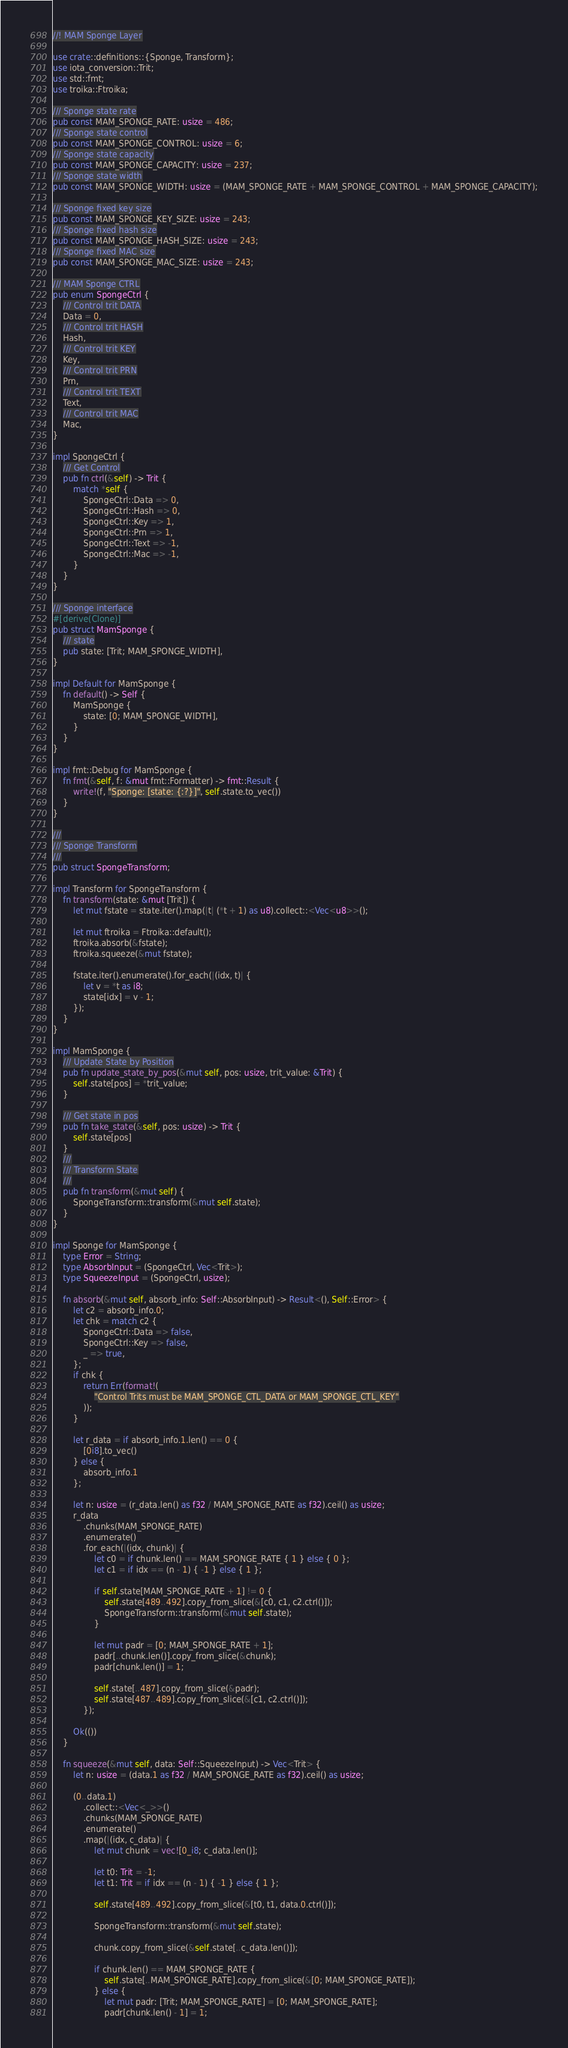<code> <loc_0><loc_0><loc_500><loc_500><_Rust_>//! MAM Sponge Layer

use crate::definitions::{Sponge, Transform};
use iota_conversion::Trit;
use std::fmt;
use troika::Ftroika;

/// Sponge state rate
pub const MAM_SPONGE_RATE: usize = 486;
/// Sponge state control
pub const MAM_SPONGE_CONTROL: usize = 6;
/// Sponge state capacity
pub const MAM_SPONGE_CAPACITY: usize = 237;
/// Sponge state width
pub const MAM_SPONGE_WIDTH: usize = (MAM_SPONGE_RATE + MAM_SPONGE_CONTROL + MAM_SPONGE_CAPACITY);

/// Sponge fixed key size
pub const MAM_SPONGE_KEY_SIZE: usize = 243;
/// Sponge fixed hash size
pub const MAM_SPONGE_HASH_SIZE: usize = 243;
/// Sponge fixed MAC size
pub const MAM_SPONGE_MAC_SIZE: usize = 243;

/// MAM Sponge CTRL
pub enum SpongeCtrl {
    /// Control trit DATA
    Data = 0,
    /// Control trit HASH
    Hash,
    /// Control trit KEY
    Key,
    /// Control trit PRN
    Prn,
    /// Control trit TEXT
    Text,
    /// Control trit MAC
    Mac,
}

impl SpongeCtrl {
    /// Get Control
    pub fn ctrl(&self) -> Trit {
        match *self {
            SpongeCtrl::Data => 0,
            SpongeCtrl::Hash => 0,
            SpongeCtrl::Key => 1,
            SpongeCtrl::Prn => 1,
            SpongeCtrl::Text => -1,
            SpongeCtrl::Mac => -1,
        }
    }
}

/// Sponge interface
#[derive(Clone)]
pub struct MamSponge {
    /// state
    pub state: [Trit; MAM_SPONGE_WIDTH],
}

impl Default for MamSponge {
    fn default() -> Self {
        MamSponge {
            state: [0; MAM_SPONGE_WIDTH],
        }
    }
}

impl fmt::Debug for MamSponge {
    fn fmt(&self, f: &mut fmt::Formatter) -> fmt::Result {
        write!(f, "Sponge: [state: {:?}]", self.state.to_vec())
    }
}

///
/// Sponge Transform
///
pub struct SpongeTransform;

impl Transform for SpongeTransform {
    fn transform(state: &mut [Trit]) {
        let mut fstate = state.iter().map(|t| (*t + 1) as u8).collect::<Vec<u8>>();

        let mut ftroika = Ftroika::default();
        ftroika.absorb(&fstate);
        ftroika.squeeze(&mut fstate);

        fstate.iter().enumerate().for_each(|(idx, t)| {
            let v = *t as i8;
            state[idx] = v - 1;
        });
    }
}

impl MamSponge {
    /// Update State by Position
    pub fn update_state_by_pos(&mut self, pos: usize, trit_value: &Trit) {
        self.state[pos] = *trit_value;
    }

    /// Get state in pos
    pub fn take_state(&self, pos: usize) -> Trit {
        self.state[pos]
    }
    ///
    /// Transform State
    ///
    pub fn transform(&mut self) {
        SpongeTransform::transform(&mut self.state);
    }
}

impl Sponge for MamSponge {
    type Error = String;
    type AbsorbInput = (SpongeCtrl, Vec<Trit>);
    type SqueezeInput = (SpongeCtrl, usize);

    fn absorb(&mut self, absorb_info: Self::AbsorbInput) -> Result<(), Self::Error> {
        let c2 = absorb_info.0;
        let chk = match c2 {
            SpongeCtrl::Data => false,
            SpongeCtrl::Key => false,
            _ => true,
        };
        if chk {
            return Err(format!(
                "Control Trits must be MAM_SPONGE_CTL_DATA or MAM_SPONGE_CTL_KEY"
            ));
        }

        let r_data = if absorb_info.1.len() == 0 {
            [0i8].to_vec()
        } else {
            absorb_info.1
        };

        let n: usize = (r_data.len() as f32 / MAM_SPONGE_RATE as f32).ceil() as usize;
        r_data
            .chunks(MAM_SPONGE_RATE)
            .enumerate()
            .for_each(|(idx, chunk)| {
                let c0 = if chunk.len() == MAM_SPONGE_RATE { 1 } else { 0 };
                let c1 = if idx == (n - 1) { -1 } else { 1 };

                if self.state[MAM_SPONGE_RATE + 1] != 0 {
                    self.state[489..492].copy_from_slice(&[c0, c1, c2.ctrl()]);
                    SpongeTransform::transform(&mut self.state);
                }

                let mut padr = [0; MAM_SPONGE_RATE + 1];
                padr[..chunk.len()].copy_from_slice(&chunk);
                padr[chunk.len()] = 1;

                self.state[..487].copy_from_slice(&padr);
                self.state[487..489].copy_from_slice(&[c1, c2.ctrl()]);
            });

        Ok(())
    }

    fn squeeze(&mut self, data: Self::SqueezeInput) -> Vec<Trit> {
        let n: usize = (data.1 as f32 / MAM_SPONGE_RATE as f32).ceil() as usize;

        (0..data.1)
            .collect::<Vec<_>>()
            .chunks(MAM_SPONGE_RATE)
            .enumerate()
            .map(|(idx, c_data)| {
                let mut chunk = vec![0_i8; c_data.len()];

                let t0: Trit = -1;
                let t1: Trit = if idx == (n - 1) { -1 } else { 1 };

                self.state[489..492].copy_from_slice(&[t0, t1, data.0.ctrl()]);

                SpongeTransform::transform(&mut self.state);

                chunk.copy_from_slice(&self.state[..c_data.len()]);

                if chunk.len() == MAM_SPONGE_RATE {
                    self.state[..MAM_SPONGE_RATE].copy_from_slice(&[0; MAM_SPONGE_RATE]);
                } else {
                    let mut padr: [Trit; MAM_SPONGE_RATE] = [0; MAM_SPONGE_RATE];
                    padr[chunk.len() - 1] = 1;</code> 